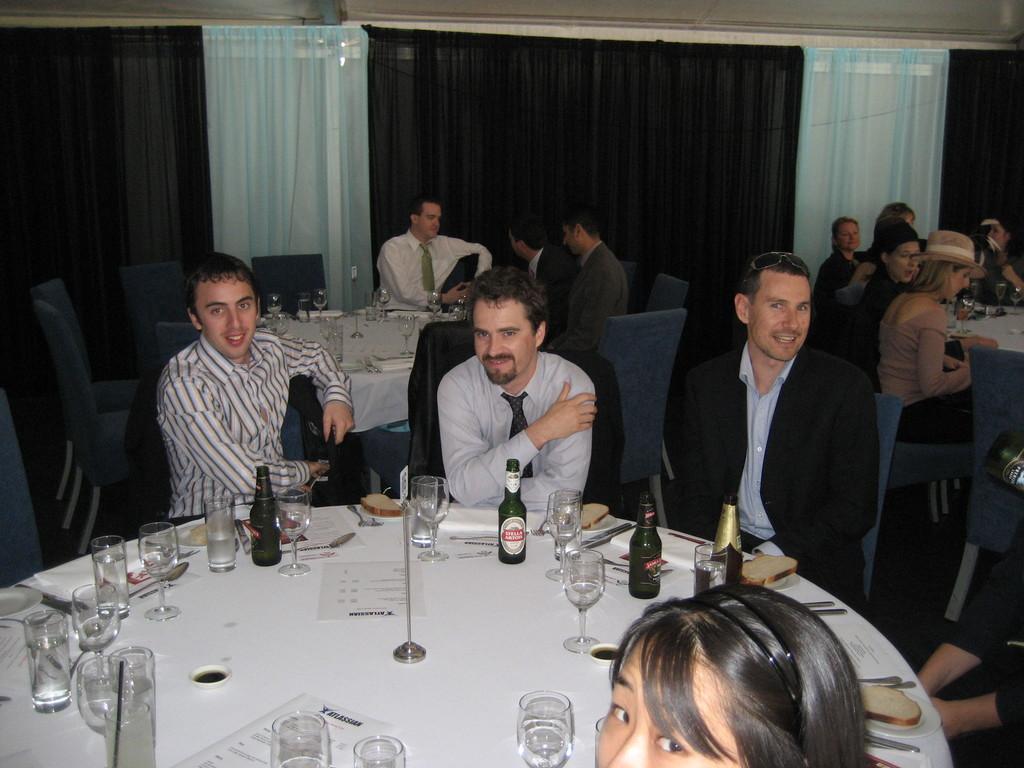Describe this image in one or two sentences. In this picture we can see a group of people sitting on chairs and in front of them there is table and on table we can see glasses, bottle, cards, bread slices on plate, spoon, knife and in background we can see curtains. 